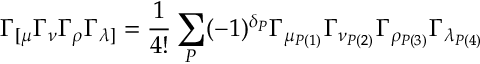<formula> <loc_0><loc_0><loc_500><loc_500>\Gamma _ { [ \mu } \Gamma _ { \nu } \Gamma _ { \rho } \Gamma _ { \lambda ] } = \frac { 1 } { 4 ! } \sum _ { P } ( - 1 ) ^ { \delta _ { P } } \Gamma _ { \mu _ { P ( 1 ) } } \Gamma _ { \nu _ { P ( 2 ) } } \Gamma _ { \rho _ { P ( 3 ) } } \Gamma _ { \lambda _ { P ( 4 ) } }</formula> 